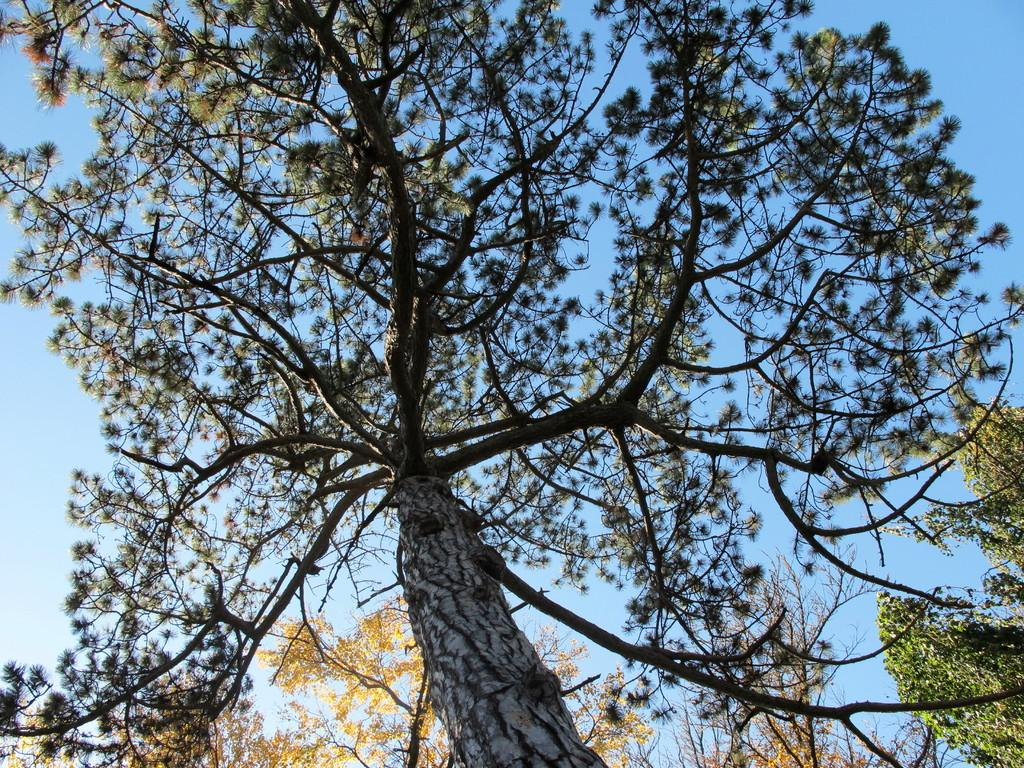What type of vegetation can be seen in the image? There are trees visible in the image. What part of the natural environment is visible in the image? The sky is visible in the background of the image. What type of yam is being served at the feast in the image? There is no feast or yam present in the image; it only features trees and the sky. 